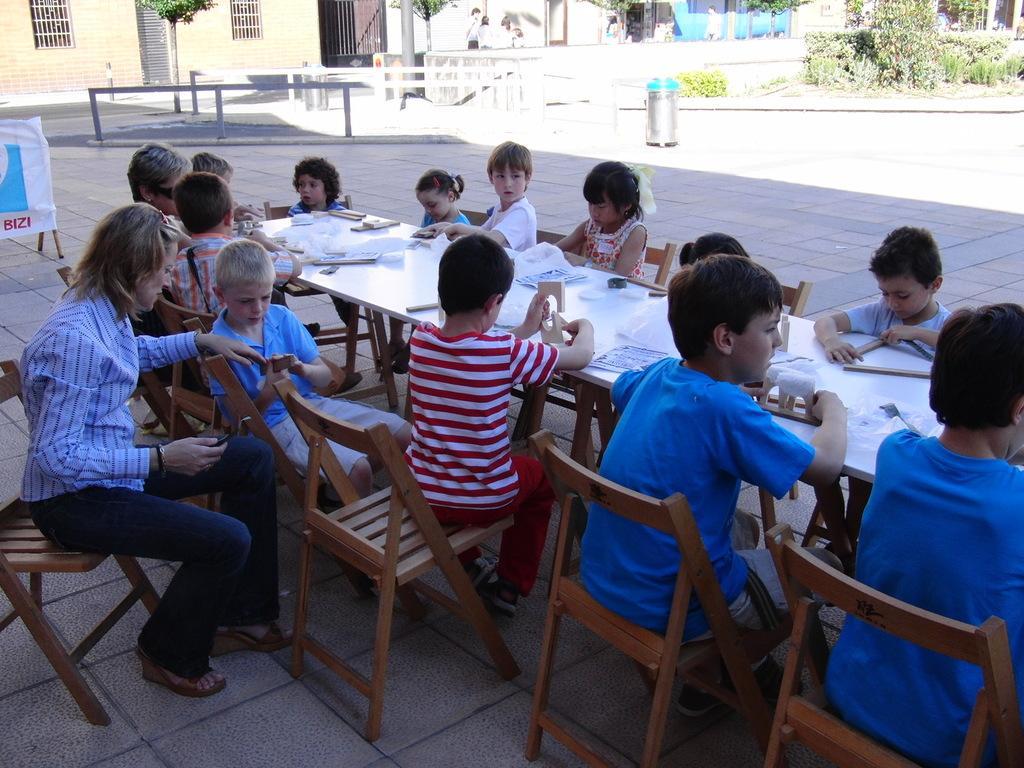Could you give a brief overview of what you see in this image? In this picture we can see a group of children sitting on chair and in front of them there is table and on table we can see papers, wooden Lego here woman sitting on chair and looking at this boy and in background we can see house with windows, pillar, fence, banner. 